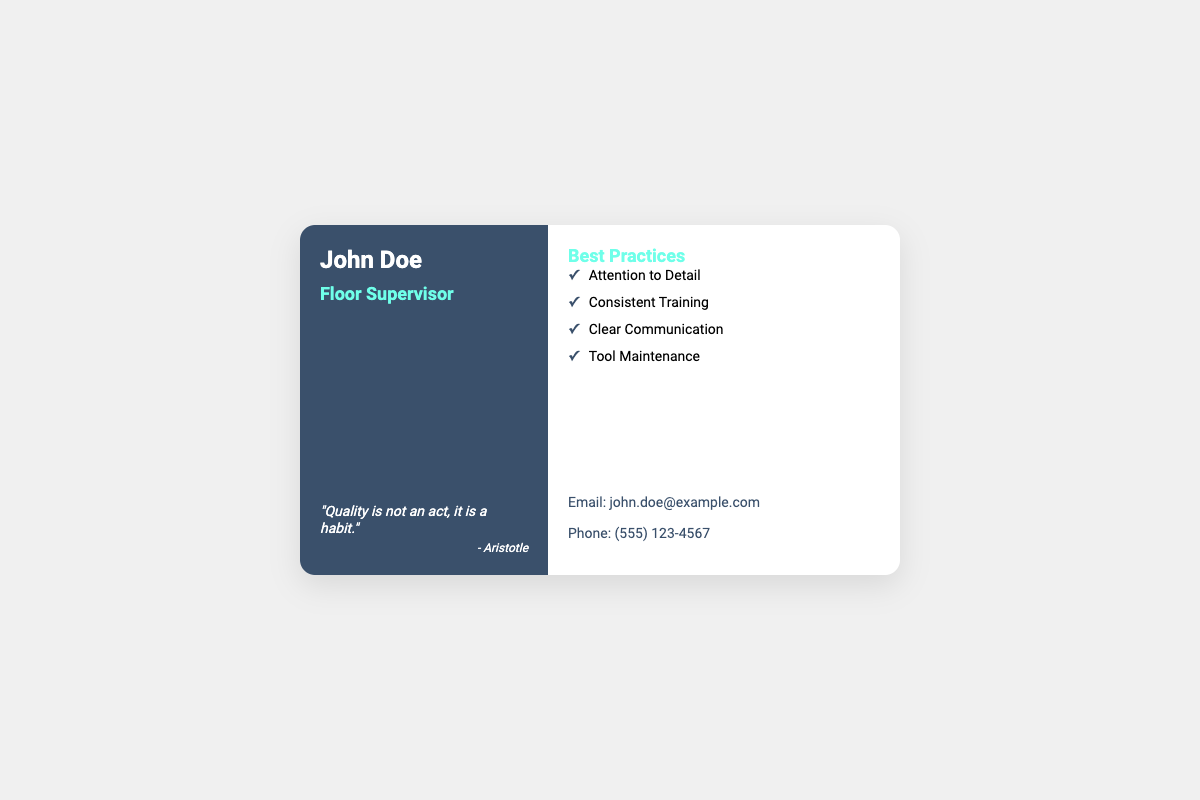What is the name of the floor supervisor? The name listed on the business card is John Doe.
Answer: John Doe What is the title of John Doe? The document specifies John Doe's title as Floor Supervisor.
Answer: Floor Supervisor What is the quote attributed to? The quote "Quality is not an act, it is a habit." is attributed to Aristotle.
Answer: Aristotle How many best practices are listed in the document? There are four best practices mentioned on the business card.
Answer: Four What is one of the best practices for maintaining high quality? One of the best practices listed is Attention to Detail.
Answer: Attention to Detail What is the email address provided on the card? The email address for John Doe is john.doe@example.com.
Answer: john.doe@example.com What color is the left panel of the business card? The left panel of the business card is colored dark blue.
Answer: Dark blue What is the font style used for the quote? The quote is presented in italic font style.
Answer: Italic What type of document is this? This document is a business card.
Answer: Business card 